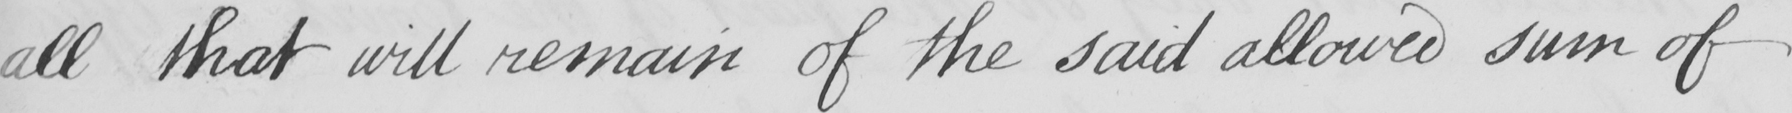What text is written in this handwritten line? all that will remain of the said allowed sum of 